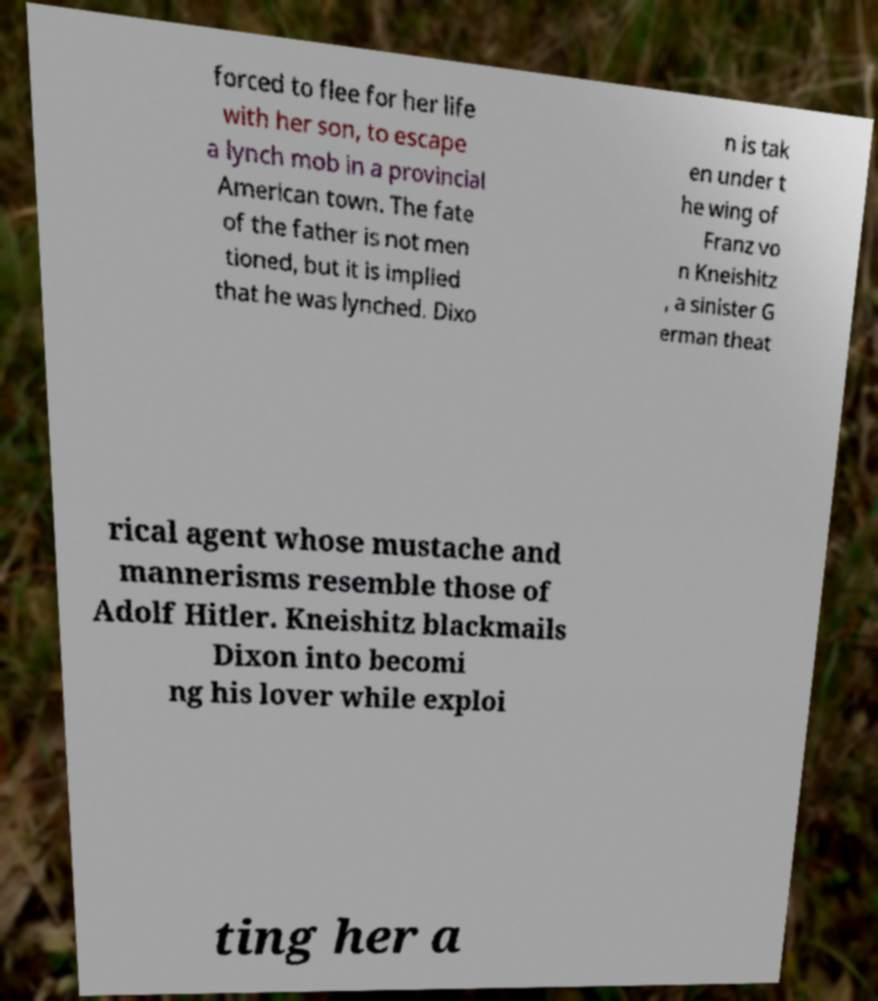There's text embedded in this image that I need extracted. Can you transcribe it verbatim? forced to flee for her life with her son, to escape a lynch mob in a provincial American town. The fate of the father is not men tioned, but it is implied that he was lynched. Dixo n is tak en under t he wing of Franz vo n Kneishitz , a sinister G erman theat rical agent whose mustache and mannerisms resemble those of Adolf Hitler. Kneishitz blackmails Dixon into becomi ng his lover while exploi ting her a 